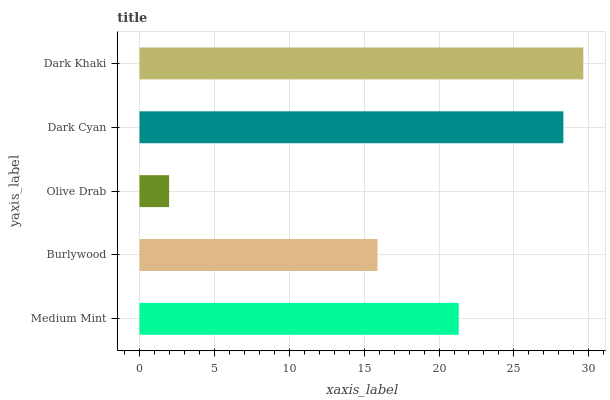Is Olive Drab the minimum?
Answer yes or no. Yes. Is Dark Khaki the maximum?
Answer yes or no. Yes. Is Burlywood the minimum?
Answer yes or no. No. Is Burlywood the maximum?
Answer yes or no. No. Is Medium Mint greater than Burlywood?
Answer yes or no. Yes. Is Burlywood less than Medium Mint?
Answer yes or no. Yes. Is Burlywood greater than Medium Mint?
Answer yes or no. No. Is Medium Mint less than Burlywood?
Answer yes or no. No. Is Medium Mint the high median?
Answer yes or no. Yes. Is Medium Mint the low median?
Answer yes or no. Yes. Is Burlywood the high median?
Answer yes or no. No. Is Olive Drab the low median?
Answer yes or no. No. 